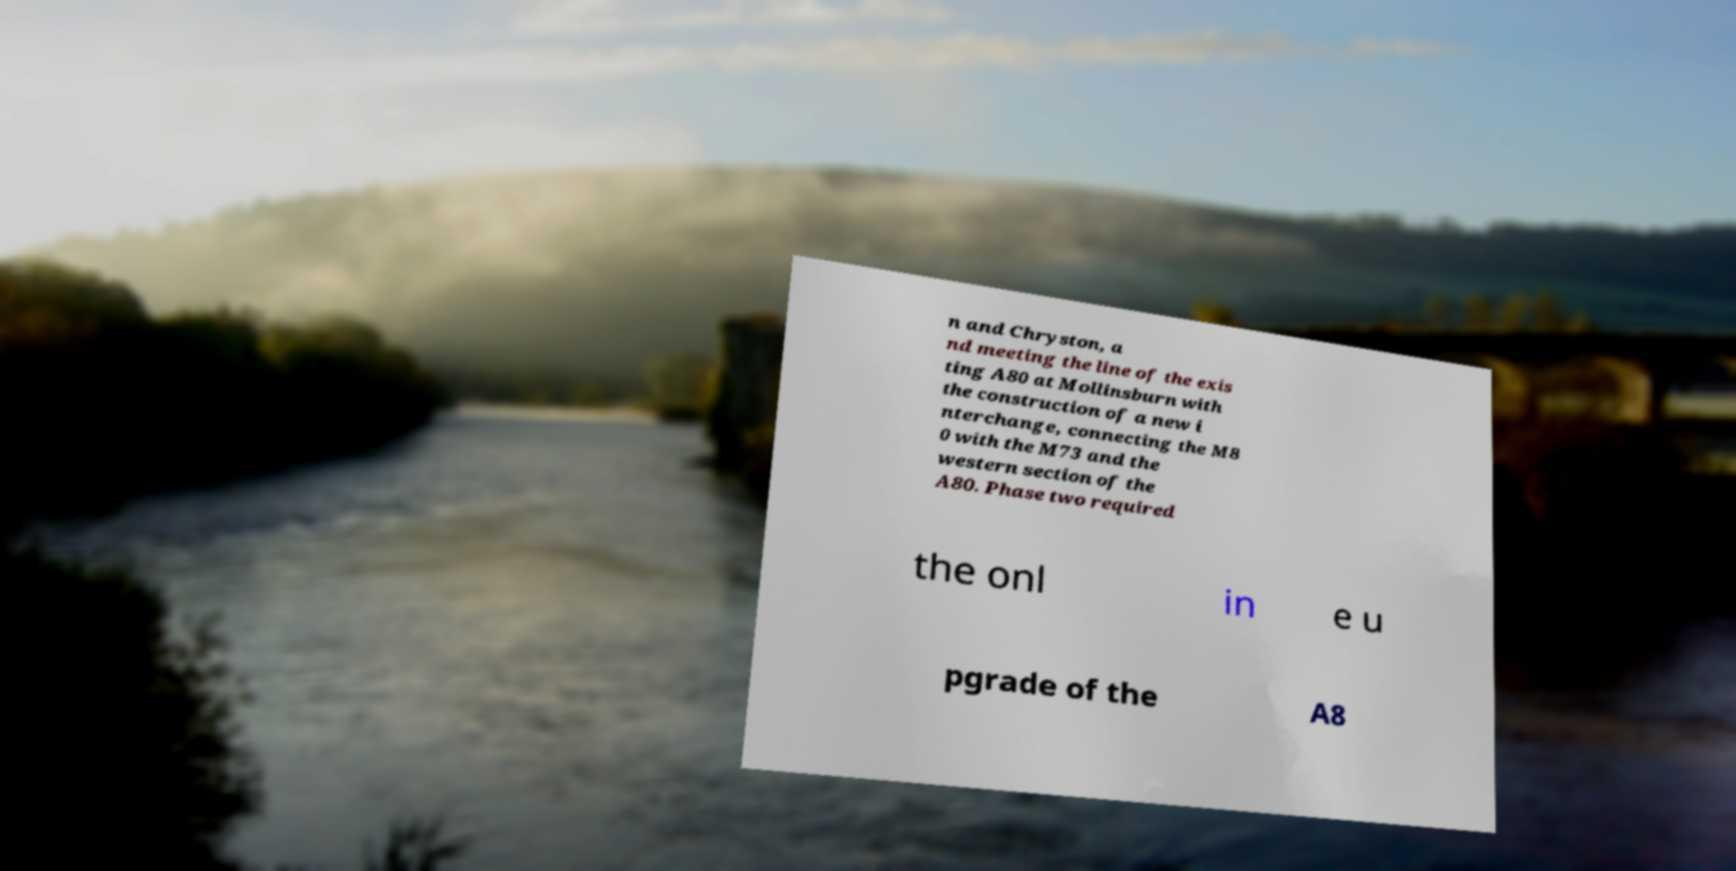Can you read and provide the text displayed in the image?This photo seems to have some interesting text. Can you extract and type it out for me? n and Chryston, a nd meeting the line of the exis ting A80 at Mollinsburn with the construction of a new i nterchange, connecting the M8 0 with the M73 and the western section of the A80. Phase two required the onl in e u pgrade of the A8 